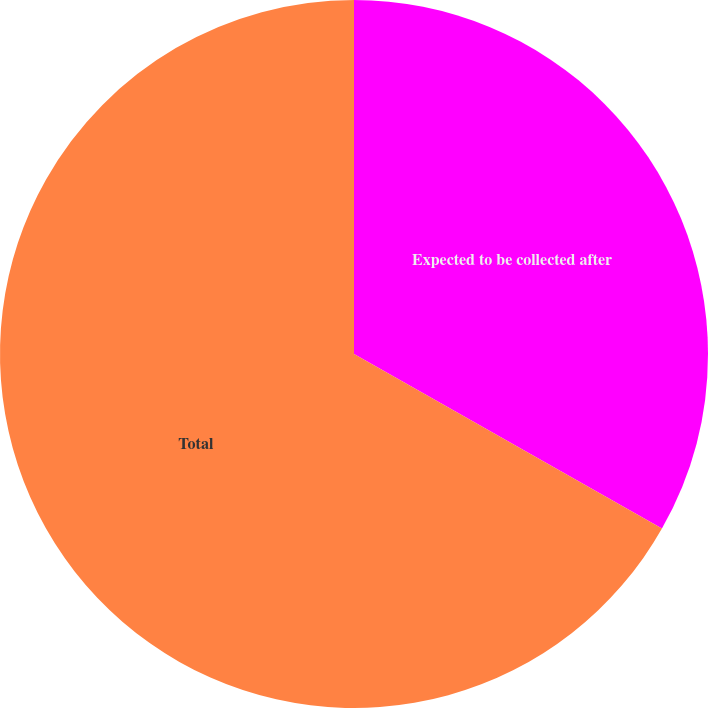Convert chart to OTSL. <chart><loc_0><loc_0><loc_500><loc_500><pie_chart><fcel>Expected to be collected after<fcel>Total<nl><fcel>33.21%<fcel>66.79%<nl></chart> 